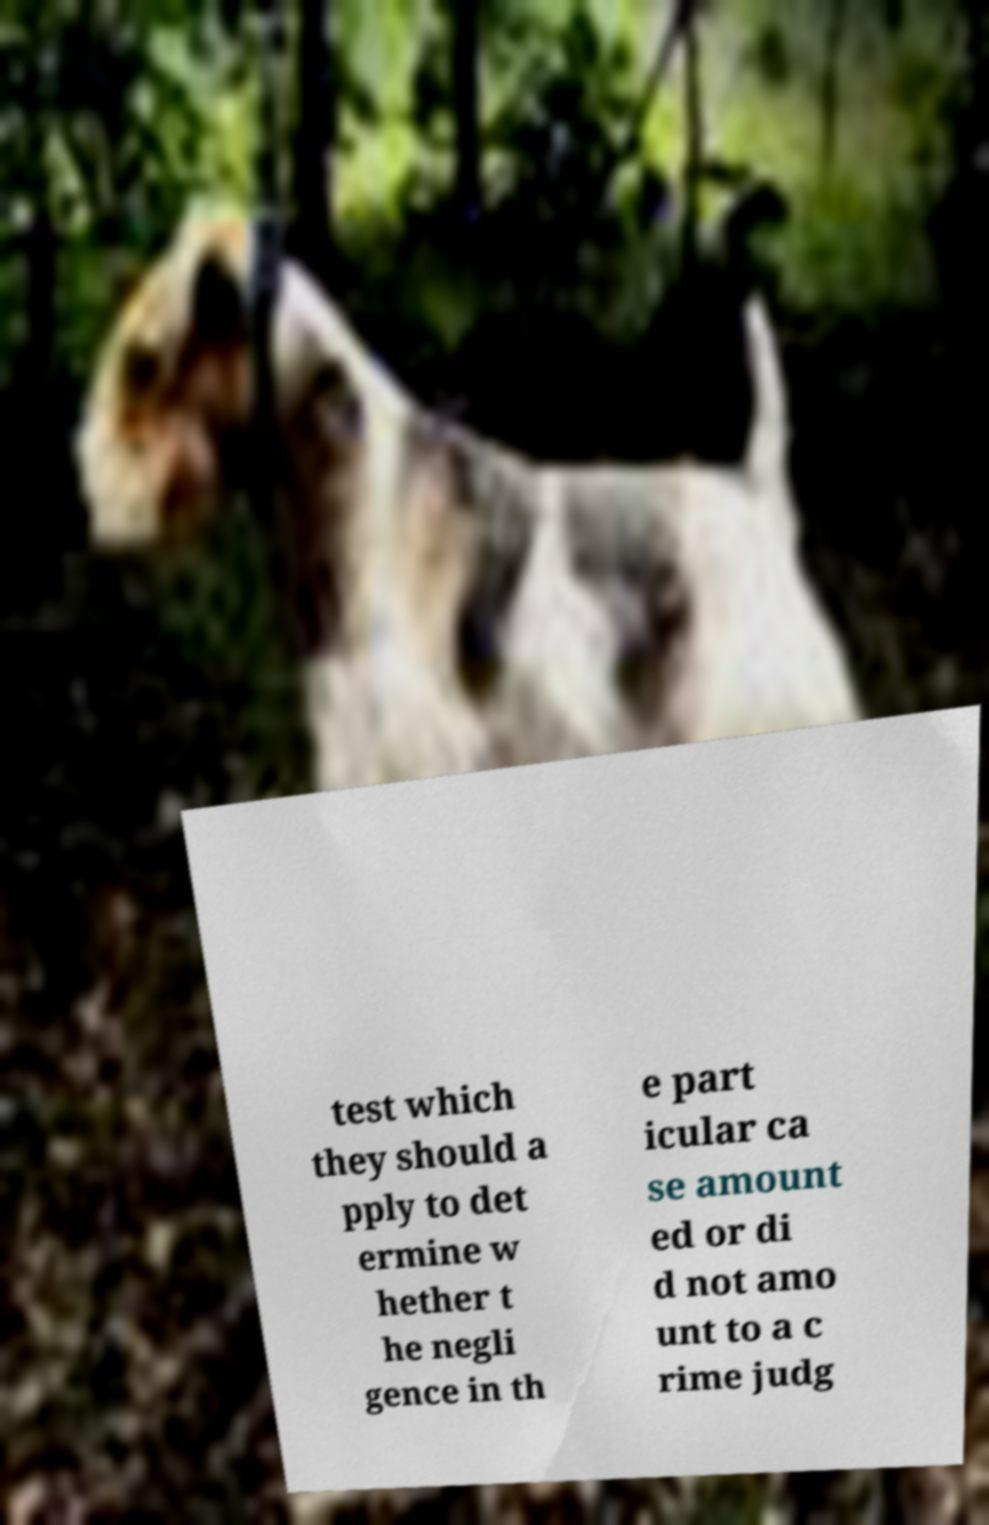For documentation purposes, I need the text within this image transcribed. Could you provide that? test which they should a pply to det ermine w hether t he negli gence in th e part icular ca se amount ed or di d not amo unt to a c rime judg 